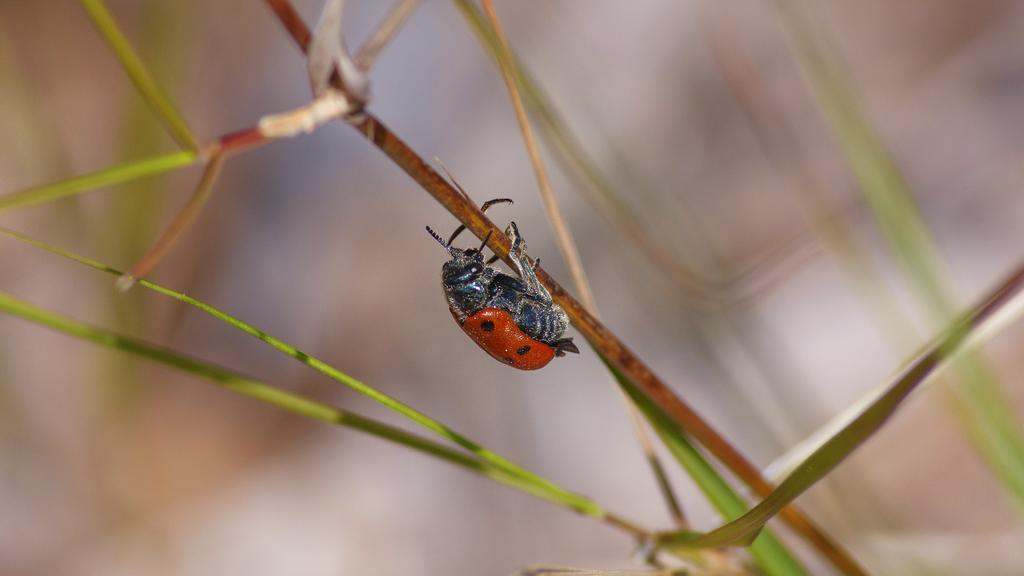How would you summarize this image in a sentence or two? In this image there is an insect on the grass. 